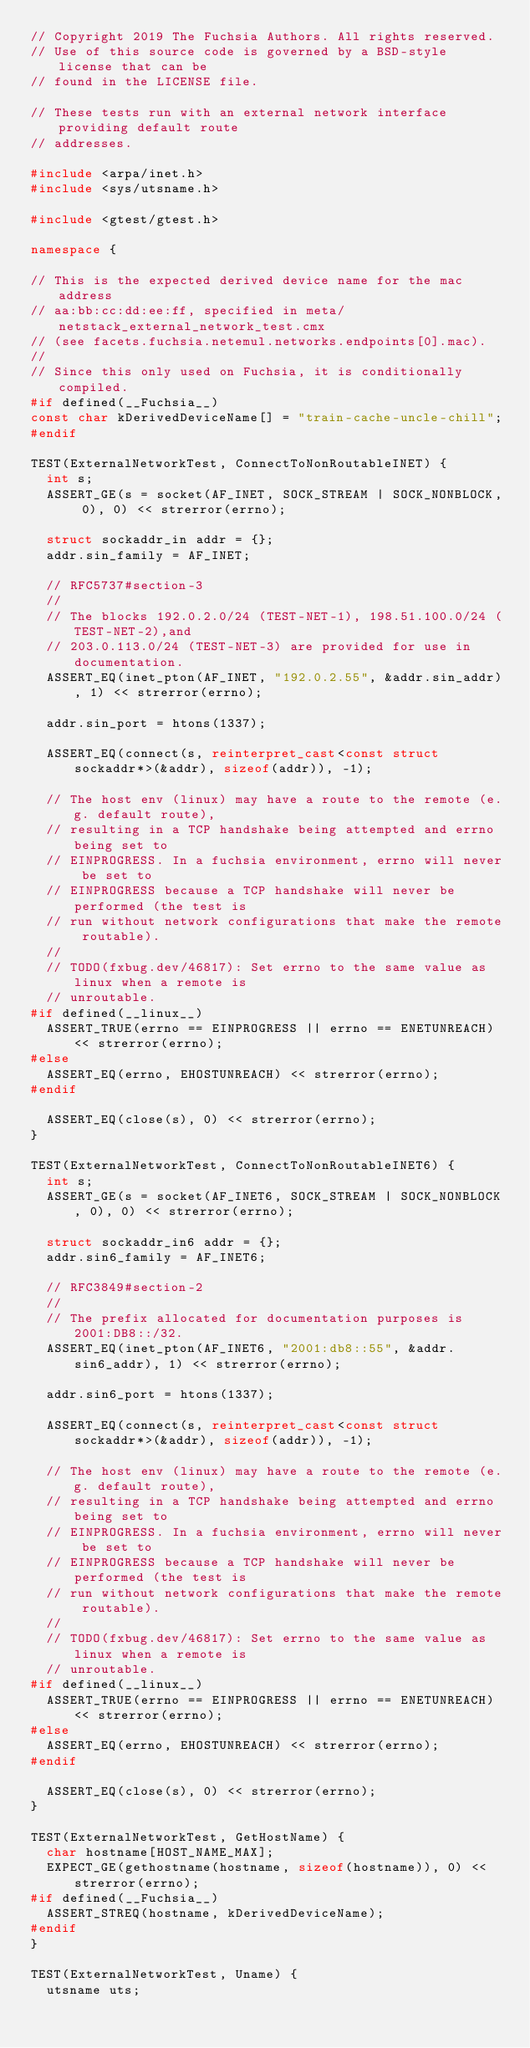<code> <loc_0><loc_0><loc_500><loc_500><_C++_>// Copyright 2019 The Fuchsia Authors. All rights reserved.
// Use of this source code is governed by a BSD-style license that can be
// found in the LICENSE file.

// These tests run with an external network interface providing default route
// addresses.

#include <arpa/inet.h>
#include <sys/utsname.h>

#include <gtest/gtest.h>

namespace {

// This is the expected derived device name for the mac address
// aa:bb:cc:dd:ee:ff, specified in meta/netstack_external_network_test.cmx
// (see facets.fuchsia.netemul.networks.endpoints[0].mac).
//
// Since this only used on Fuchsia, it is conditionally compiled.
#if defined(__Fuchsia__)
const char kDerivedDeviceName[] = "train-cache-uncle-chill";
#endif

TEST(ExternalNetworkTest, ConnectToNonRoutableINET) {
  int s;
  ASSERT_GE(s = socket(AF_INET, SOCK_STREAM | SOCK_NONBLOCK, 0), 0) << strerror(errno);

  struct sockaddr_in addr = {};
  addr.sin_family = AF_INET;

  // RFC5737#section-3
  //
  // The blocks 192.0.2.0/24 (TEST-NET-1), 198.51.100.0/24 (TEST-NET-2),and
  // 203.0.113.0/24 (TEST-NET-3) are provided for use in documentation.
  ASSERT_EQ(inet_pton(AF_INET, "192.0.2.55", &addr.sin_addr), 1) << strerror(errno);

  addr.sin_port = htons(1337);

  ASSERT_EQ(connect(s, reinterpret_cast<const struct sockaddr*>(&addr), sizeof(addr)), -1);

  // The host env (linux) may have a route to the remote (e.g. default route),
  // resulting in a TCP handshake being attempted and errno being set to
  // EINPROGRESS. In a fuchsia environment, errno will never be set to
  // EINPROGRESS because a TCP handshake will never be performed (the test is
  // run without network configurations that make the remote routable).
  //
  // TODO(fxbug.dev/46817): Set errno to the same value as linux when a remote is
  // unroutable.
#if defined(__linux__)
  ASSERT_TRUE(errno == EINPROGRESS || errno == ENETUNREACH) << strerror(errno);
#else
  ASSERT_EQ(errno, EHOSTUNREACH) << strerror(errno);
#endif

  ASSERT_EQ(close(s), 0) << strerror(errno);
}

TEST(ExternalNetworkTest, ConnectToNonRoutableINET6) {
  int s;
  ASSERT_GE(s = socket(AF_INET6, SOCK_STREAM | SOCK_NONBLOCK, 0), 0) << strerror(errno);

  struct sockaddr_in6 addr = {};
  addr.sin6_family = AF_INET6;

  // RFC3849#section-2
  //
  // The prefix allocated for documentation purposes is 2001:DB8::/32.
  ASSERT_EQ(inet_pton(AF_INET6, "2001:db8::55", &addr.sin6_addr), 1) << strerror(errno);

  addr.sin6_port = htons(1337);

  ASSERT_EQ(connect(s, reinterpret_cast<const struct sockaddr*>(&addr), sizeof(addr)), -1);

  // The host env (linux) may have a route to the remote (e.g. default route),
  // resulting in a TCP handshake being attempted and errno being set to
  // EINPROGRESS. In a fuchsia environment, errno will never be set to
  // EINPROGRESS because a TCP handshake will never be performed (the test is
  // run without network configurations that make the remote routable).
  //
  // TODO(fxbug.dev/46817): Set errno to the same value as linux when a remote is
  // unroutable.
#if defined(__linux__)
  ASSERT_TRUE(errno == EINPROGRESS || errno == ENETUNREACH) << strerror(errno);
#else
  ASSERT_EQ(errno, EHOSTUNREACH) << strerror(errno);
#endif

  ASSERT_EQ(close(s), 0) << strerror(errno);
}

TEST(ExternalNetworkTest, GetHostName) {
  char hostname[HOST_NAME_MAX];
  EXPECT_GE(gethostname(hostname, sizeof(hostname)), 0) << strerror(errno);
#if defined(__Fuchsia__)
  ASSERT_STREQ(hostname, kDerivedDeviceName);
#endif
}

TEST(ExternalNetworkTest, Uname) {
  utsname uts;</code> 